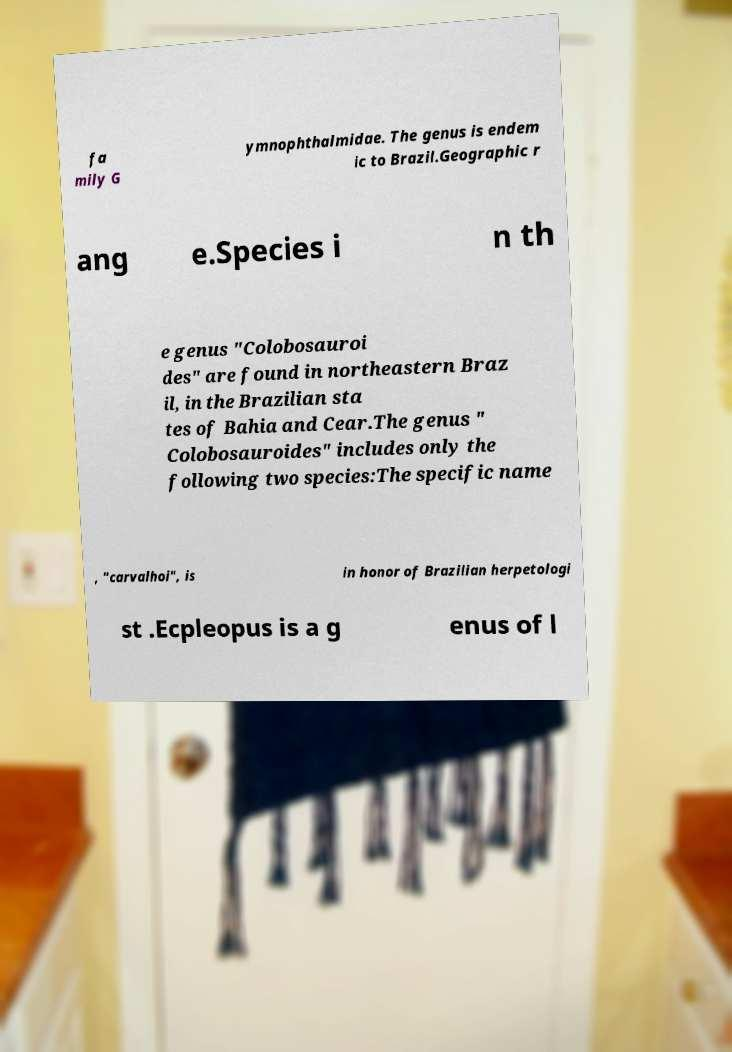What messages or text are displayed in this image? I need them in a readable, typed format. fa mily G ymnophthalmidae. The genus is endem ic to Brazil.Geographic r ang e.Species i n th e genus "Colobosauroi des" are found in northeastern Braz il, in the Brazilian sta tes of Bahia and Cear.The genus " Colobosauroides" includes only the following two species:The specific name , "carvalhoi", is in honor of Brazilian herpetologi st .Ecpleopus is a g enus of l 